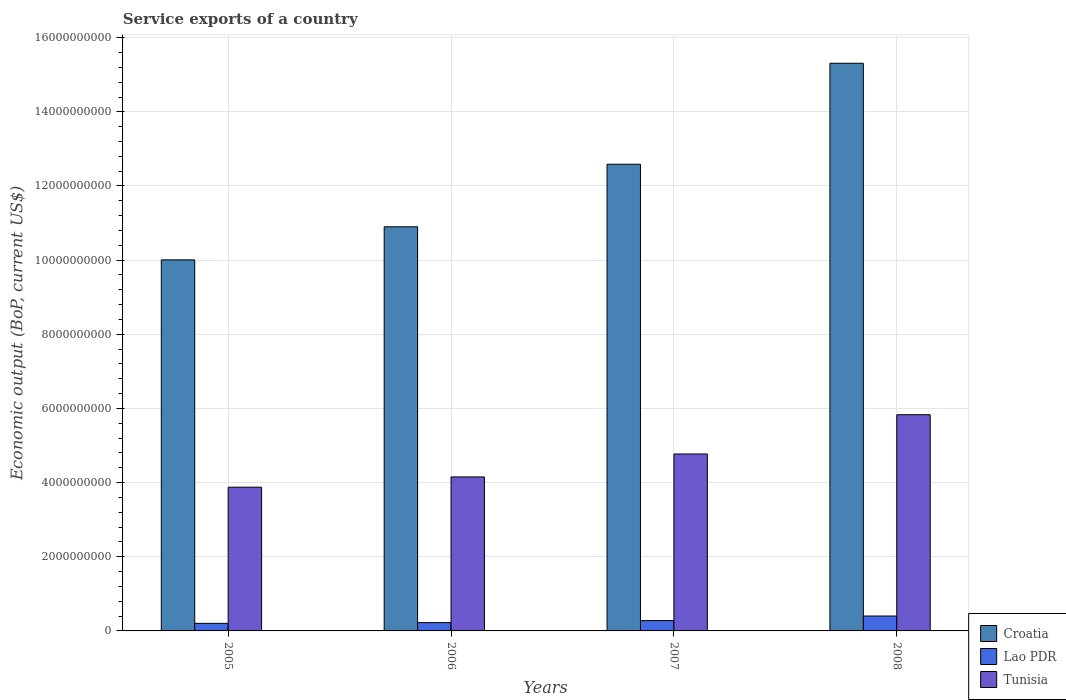How many different coloured bars are there?
Your answer should be compact. 3. In how many cases, is the number of bars for a given year not equal to the number of legend labels?
Give a very brief answer. 0. What is the service exports in Lao PDR in 2006?
Provide a short and direct response. 2.23e+08. Across all years, what is the maximum service exports in Lao PDR?
Your response must be concise. 4.02e+08. Across all years, what is the minimum service exports in Lao PDR?
Your answer should be very brief. 2.04e+08. In which year was the service exports in Croatia maximum?
Your response must be concise. 2008. What is the total service exports in Tunisia in the graph?
Ensure brevity in your answer.  1.86e+1. What is the difference between the service exports in Lao PDR in 2006 and that in 2007?
Provide a succinct answer. -5.47e+07. What is the difference between the service exports in Lao PDR in 2007 and the service exports in Tunisia in 2008?
Your answer should be compact. -5.55e+09. What is the average service exports in Croatia per year?
Your answer should be compact. 1.22e+1. In the year 2008, what is the difference between the service exports in Croatia and service exports in Tunisia?
Offer a very short reply. 9.48e+09. In how many years, is the service exports in Lao PDR greater than 4000000000 US$?
Offer a terse response. 0. What is the ratio of the service exports in Tunisia in 2007 to that in 2008?
Provide a short and direct response. 0.82. Is the service exports in Lao PDR in 2006 less than that in 2008?
Make the answer very short. Yes. What is the difference between the highest and the second highest service exports in Tunisia?
Offer a very short reply. 1.06e+09. What is the difference between the highest and the lowest service exports in Tunisia?
Your response must be concise. 1.95e+09. Is the sum of the service exports in Tunisia in 2007 and 2008 greater than the maximum service exports in Lao PDR across all years?
Your answer should be compact. Yes. What does the 3rd bar from the left in 2005 represents?
Provide a short and direct response. Tunisia. What does the 3rd bar from the right in 2005 represents?
Provide a short and direct response. Croatia. Is it the case that in every year, the sum of the service exports in Croatia and service exports in Lao PDR is greater than the service exports in Tunisia?
Your answer should be compact. Yes. How many bars are there?
Offer a terse response. 12. Are the values on the major ticks of Y-axis written in scientific E-notation?
Offer a terse response. No. Does the graph contain any zero values?
Keep it short and to the point. No. How many legend labels are there?
Offer a terse response. 3. What is the title of the graph?
Your answer should be very brief. Service exports of a country. What is the label or title of the X-axis?
Give a very brief answer. Years. What is the label or title of the Y-axis?
Your answer should be compact. Economic output (BoP, current US$). What is the Economic output (BoP, current US$) of Croatia in 2005?
Keep it short and to the point. 1.00e+1. What is the Economic output (BoP, current US$) of Lao PDR in 2005?
Your answer should be very brief. 2.04e+08. What is the Economic output (BoP, current US$) in Tunisia in 2005?
Your answer should be compact. 3.88e+09. What is the Economic output (BoP, current US$) of Croatia in 2006?
Your answer should be very brief. 1.09e+1. What is the Economic output (BoP, current US$) of Lao PDR in 2006?
Keep it short and to the point. 2.23e+08. What is the Economic output (BoP, current US$) of Tunisia in 2006?
Ensure brevity in your answer.  4.15e+09. What is the Economic output (BoP, current US$) of Croatia in 2007?
Your answer should be compact. 1.26e+1. What is the Economic output (BoP, current US$) of Lao PDR in 2007?
Your response must be concise. 2.78e+08. What is the Economic output (BoP, current US$) in Tunisia in 2007?
Keep it short and to the point. 4.77e+09. What is the Economic output (BoP, current US$) of Croatia in 2008?
Your answer should be compact. 1.53e+1. What is the Economic output (BoP, current US$) in Lao PDR in 2008?
Give a very brief answer. 4.02e+08. What is the Economic output (BoP, current US$) in Tunisia in 2008?
Offer a very short reply. 5.83e+09. Across all years, what is the maximum Economic output (BoP, current US$) in Croatia?
Offer a very short reply. 1.53e+1. Across all years, what is the maximum Economic output (BoP, current US$) in Lao PDR?
Offer a very short reply. 4.02e+08. Across all years, what is the maximum Economic output (BoP, current US$) in Tunisia?
Provide a succinct answer. 5.83e+09. Across all years, what is the minimum Economic output (BoP, current US$) in Croatia?
Provide a succinct answer. 1.00e+1. Across all years, what is the minimum Economic output (BoP, current US$) of Lao PDR?
Make the answer very short. 2.04e+08. Across all years, what is the minimum Economic output (BoP, current US$) of Tunisia?
Make the answer very short. 3.88e+09. What is the total Economic output (BoP, current US$) in Croatia in the graph?
Your response must be concise. 4.88e+1. What is the total Economic output (BoP, current US$) in Lao PDR in the graph?
Provide a short and direct response. 1.11e+09. What is the total Economic output (BoP, current US$) of Tunisia in the graph?
Make the answer very short. 1.86e+1. What is the difference between the Economic output (BoP, current US$) in Croatia in 2005 and that in 2006?
Your response must be concise. -8.92e+08. What is the difference between the Economic output (BoP, current US$) of Lao PDR in 2005 and that in 2006?
Provide a succinct answer. -1.92e+07. What is the difference between the Economic output (BoP, current US$) of Tunisia in 2005 and that in 2006?
Give a very brief answer. -2.76e+08. What is the difference between the Economic output (BoP, current US$) in Croatia in 2005 and that in 2007?
Offer a terse response. -2.58e+09. What is the difference between the Economic output (BoP, current US$) in Lao PDR in 2005 and that in 2007?
Your answer should be very brief. -7.39e+07. What is the difference between the Economic output (BoP, current US$) in Tunisia in 2005 and that in 2007?
Your answer should be very brief. -8.95e+08. What is the difference between the Economic output (BoP, current US$) of Croatia in 2005 and that in 2008?
Offer a terse response. -5.30e+09. What is the difference between the Economic output (BoP, current US$) in Lao PDR in 2005 and that in 2008?
Your answer should be compact. -1.97e+08. What is the difference between the Economic output (BoP, current US$) of Tunisia in 2005 and that in 2008?
Provide a succinct answer. -1.95e+09. What is the difference between the Economic output (BoP, current US$) of Croatia in 2006 and that in 2007?
Keep it short and to the point. -1.69e+09. What is the difference between the Economic output (BoP, current US$) in Lao PDR in 2006 and that in 2007?
Your answer should be very brief. -5.47e+07. What is the difference between the Economic output (BoP, current US$) in Tunisia in 2006 and that in 2007?
Offer a very short reply. -6.19e+08. What is the difference between the Economic output (BoP, current US$) in Croatia in 2006 and that in 2008?
Ensure brevity in your answer.  -4.41e+09. What is the difference between the Economic output (BoP, current US$) in Lao PDR in 2006 and that in 2008?
Your response must be concise. -1.78e+08. What is the difference between the Economic output (BoP, current US$) of Tunisia in 2006 and that in 2008?
Make the answer very short. -1.68e+09. What is the difference between the Economic output (BoP, current US$) in Croatia in 2007 and that in 2008?
Ensure brevity in your answer.  -2.72e+09. What is the difference between the Economic output (BoP, current US$) in Lao PDR in 2007 and that in 2008?
Your answer should be compact. -1.23e+08. What is the difference between the Economic output (BoP, current US$) in Tunisia in 2007 and that in 2008?
Provide a succinct answer. -1.06e+09. What is the difference between the Economic output (BoP, current US$) of Croatia in 2005 and the Economic output (BoP, current US$) of Lao PDR in 2006?
Give a very brief answer. 9.78e+09. What is the difference between the Economic output (BoP, current US$) in Croatia in 2005 and the Economic output (BoP, current US$) in Tunisia in 2006?
Offer a terse response. 5.85e+09. What is the difference between the Economic output (BoP, current US$) of Lao PDR in 2005 and the Economic output (BoP, current US$) of Tunisia in 2006?
Give a very brief answer. -3.95e+09. What is the difference between the Economic output (BoP, current US$) of Croatia in 2005 and the Economic output (BoP, current US$) of Lao PDR in 2007?
Make the answer very short. 9.73e+09. What is the difference between the Economic output (BoP, current US$) of Croatia in 2005 and the Economic output (BoP, current US$) of Tunisia in 2007?
Provide a succinct answer. 5.24e+09. What is the difference between the Economic output (BoP, current US$) in Lao PDR in 2005 and the Economic output (BoP, current US$) in Tunisia in 2007?
Provide a short and direct response. -4.57e+09. What is the difference between the Economic output (BoP, current US$) of Croatia in 2005 and the Economic output (BoP, current US$) of Lao PDR in 2008?
Your answer should be very brief. 9.61e+09. What is the difference between the Economic output (BoP, current US$) in Croatia in 2005 and the Economic output (BoP, current US$) in Tunisia in 2008?
Give a very brief answer. 4.18e+09. What is the difference between the Economic output (BoP, current US$) of Lao PDR in 2005 and the Economic output (BoP, current US$) of Tunisia in 2008?
Offer a terse response. -5.63e+09. What is the difference between the Economic output (BoP, current US$) of Croatia in 2006 and the Economic output (BoP, current US$) of Lao PDR in 2007?
Ensure brevity in your answer.  1.06e+1. What is the difference between the Economic output (BoP, current US$) in Croatia in 2006 and the Economic output (BoP, current US$) in Tunisia in 2007?
Give a very brief answer. 6.13e+09. What is the difference between the Economic output (BoP, current US$) in Lao PDR in 2006 and the Economic output (BoP, current US$) in Tunisia in 2007?
Provide a short and direct response. -4.55e+09. What is the difference between the Economic output (BoP, current US$) in Croatia in 2006 and the Economic output (BoP, current US$) in Lao PDR in 2008?
Provide a short and direct response. 1.05e+1. What is the difference between the Economic output (BoP, current US$) of Croatia in 2006 and the Economic output (BoP, current US$) of Tunisia in 2008?
Make the answer very short. 5.07e+09. What is the difference between the Economic output (BoP, current US$) in Lao PDR in 2006 and the Economic output (BoP, current US$) in Tunisia in 2008?
Your answer should be very brief. -5.61e+09. What is the difference between the Economic output (BoP, current US$) in Croatia in 2007 and the Economic output (BoP, current US$) in Lao PDR in 2008?
Your response must be concise. 1.22e+1. What is the difference between the Economic output (BoP, current US$) in Croatia in 2007 and the Economic output (BoP, current US$) in Tunisia in 2008?
Give a very brief answer. 6.75e+09. What is the difference between the Economic output (BoP, current US$) of Lao PDR in 2007 and the Economic output (BoP, current US$) of Tunisia in 2008?
Provide a short and direct response. -5.55e+09. What is the average Economic output (BoP, current US$) of Croatia per year?
Your answer should be very brief. 1.22e+1. What is the average Economic output (BoP, current US$) of Lao PDR per year?
Make the answer very short. 2.77e+08. What is the average Economic output (BoP, current US$) in Tunisia per year?
Offer a very short reply. 4.66e+09. In the year 2005, what is the difference between the Economic output (BoP, current US$) in Croatia and Economic output (BoP, current US$) in Lao PDR?
Provide a short and direct response. 9.80e+09. In the year 2005, what is the difference between the Economic output (BoP, current US$) of Croatia and Economic output (BoP, current US$) of Tunisia?
Your answer should be very brief. 6.13e+09. In the year 2005, what is the difference between the Economic output (BoP, current US$) of Lao PDR and Economic output (BoP, current US$) of Tunisia?
Make the answer very short. -3.67e+09. In the year 2006, what is the difference between the Economic output (BoP, current US$) in Croatia and Economic output (BoP, current US$) in Lao PDR?
Provide a succinct answer. 1.07e+1. In the year 2006, what is the difference between the Economic output (BoP, current US$) of Croatia and Economic output (BoP, current US$) of Tunisia?
Your answer should be compact. 6.75e+09. In the year 2006, what is the difference between the Economic output (BoP, current US$) of Lao PDR and Economic output (BoP, current US$) of Tunisia?
Offer a terse response. -3.93e+09. In the year 2007, what is the difference between the Economic output (BoP, current US$) of Croatia and Economic output (BoP, current US$) of Lao PDR?
Your response must be concise. 1.23e+1. In the year 2007, what is the difference between the Economic output (BoP, current US$) in Croatia and Economic output (BoP, current US$) in Tunisia?
Make the answer very short. 7.81e+09. In the year 2007, what is the difference between the Economic output (BoP, current US$) in Lao PDR and Economic output (BoP, current US$) in Tunisia?
Ensure brevity in your answer.  -4.49e+09. In the year 2008, what is the difference between the Economic output (BoP, current US$) of Croatia and Economic output (BoP, current US$) of Lao PDR?
Your answer should be very brief. 1.49e+1. In the year 2008, what is the difference between the Economic output (BoP, current US$) in Croatia and Economic output (BoP, current US$) in Tunisia?
Your answer should be very brief. 9.48e+09. In the year 2008, what is the difference between the Economic output (BoP, current US$) in Lao PDR and Economic output (BoP, current US$) in Tunisia?
Offer a very short reply. -5.43e+09. What is the ratio of the Economic output (BoP, current US$) of Croatia in 2005 to that in 2006?
Provide a succinct answer. 0.92. What is the ratio of the Economic output (BoP, current US$) in Lao PDR in 2005 to that in 2006?
Your answer should be compact. 0.91. What is the ratio of the Economic output (BoP, current US$) of Tunisia in 2005 to that in 2006?
Keep it short and to the point. 0.93. What is the ratio of the Economic output (BoP, current US$) in Croatia in 2005 to that in 2007?
Keep it short and to the point. 0.8. What is the ratio of the Economic output (BoP, current US$) of Lao PDR in 2005 to that in 2007?
Offer a very short reply. 0.73. What is the ratio of the Economic output (BoP, current US$) of Tunisia in 2005 to that in 2007?
Provide a short and direct response. 0.81. What is the ratio of the Economic output (BoP, current US$) of Croatia in 2005 to that in 2008?
Provide a short and direct response. 0.65. What is the ratio of the Economic output (BoP, current US$) in Lao PDR in 2005 to that in 2008?
Ensure brevity in your answer.  0.51. What is the ratio of the Economic output (BoP, current US$) of Tunisia in 2005 to that in 2008?
Offer a terse response. 0.66. What is the ratio of the Economic output (BoP, current US$) of Croatia in 2006 to that in 2007?
Offer a very short reply. 0.87. What is the ratio of the Economic output (BoP, current US$) in Lao PDR in 2006 to that in 2007?
Offer a very short reply. 0.8. What is the ratio of the Economic output (BoP, current US$) in Tunisia in 2006 to that in 2007?
Ensure brevity in your answer.  0.87. What is the ratio of the Economic output (BoP, current US$) of Croatia in 2006 to that in 2008?
Your answer should be very brief. 0.71. What is the ratio of the Economic output (BoP, current US$) in Lao PDR in 2006 to that in 2008?
Offer a very short reply. 0.56. What is the ratio of the Economic output (BoP, current US$) of Tunisia in 2006 to that in 2008?
Offer a very short reply. 0.71. What is the ratio of the Economic output (BoP, current US$) of Croatia in 2007 to that in 2008?
Offer a very short reply. 0.82. What is the ratio of the Economic output (BoP, current US$) in Lao PDR in 2007 to that in 2008?
Give a very brief answer. 0.69. What is the ratio of the Economic output (BoP, current US$) of Tunisia in 2007 to that in 2008?
Provide a succinct answer. 0.82. What is the difference between the highest and the second highest Economic output (BoP, current US$) in Croatia?
Provide a succinct answer. 2.72e+09. What is the difference between the highest and the second highest Economic output (BoP, current US$) in Lao PDR?
Ensure brevity in your answer.  1.23e+08. What is the difference between the highest and the second highest Economic output (BoP, current US$) in Tunisia?
Offer a terse response. 1.06e+09. What is the difference between the highest and the lowest Economic output (BoP, current US$) of Croatia?
Offer a terse response. 5.30e+09. What is the difference between the highest and the lowest Economic output (BoP, current US$) in Lao PDR?
Provide a succinct answer. 1.97e+08. What is the difference between the highest and the lowest Economic output (BoP, current US$) of Tunisia?
Your answer should be compact. 1.95e+09. 